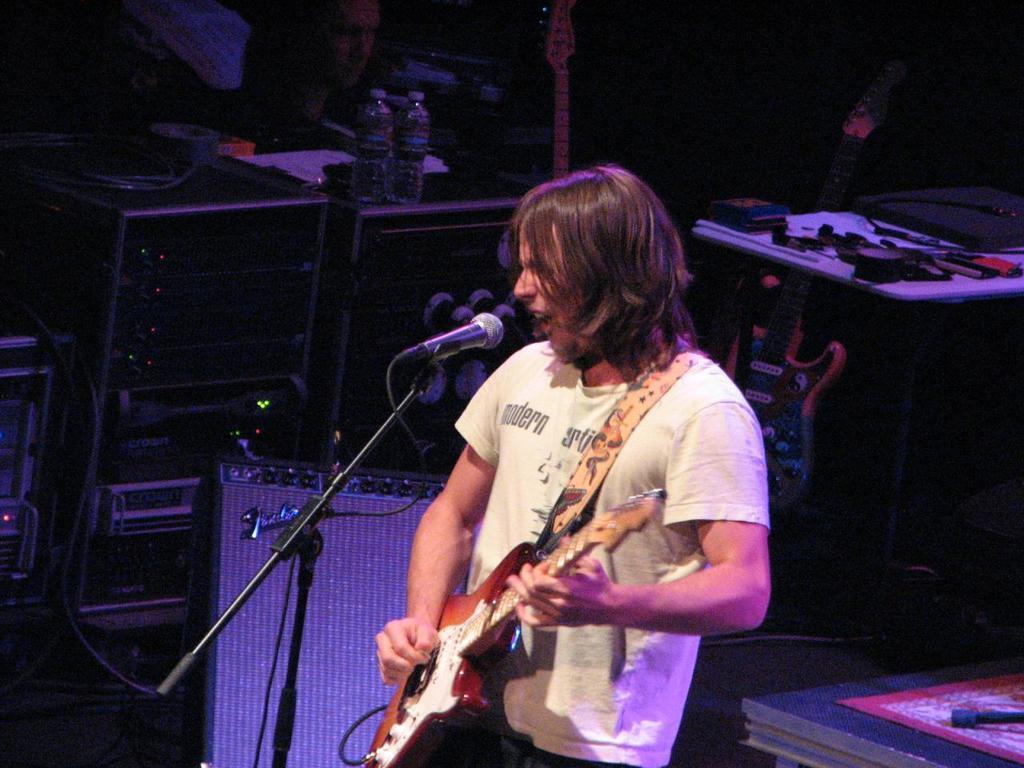How would you summarize this image in a sentence or two? This picture is of inside. In the center there is a man wearing white color t-shirt ,playing guitar, standing and singing. There is a microphone attached to the stand and we can see the speakers behind him and two bottles and papers placed on the top of the speaker. On the right we can see a guitar placed on the ground and some items placed on the top of the table. In the background we can see a person. 